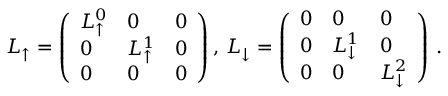<formula> <loc_0><loc_0><loc_500><loc_500>\begin{array} { r } { L _ { \uparrow } = \left ( \begin{array} { l l l } { L _ { \uparrow } ^ { 0 } } & { 0 } & { 0 } \\ { 0 } & { L _ { \uparrow } ^ { 1 } } & { 0 } \\ { 0 } & { 0 } & { 0 } \end{array} \right ) , \, L _ { \downarrow } = \left ( \begin{array} { l l l } { 0 } & { 0 } & { 0 } \\ { 0 } & { L _ { \downarrow } ^ { 1 } } & { 0 } \\ { 0 } & { 0 } & { L _ { \downarrow } ^ { 2 } } \end{array} \right ) \, . } \end{array}</formula> 